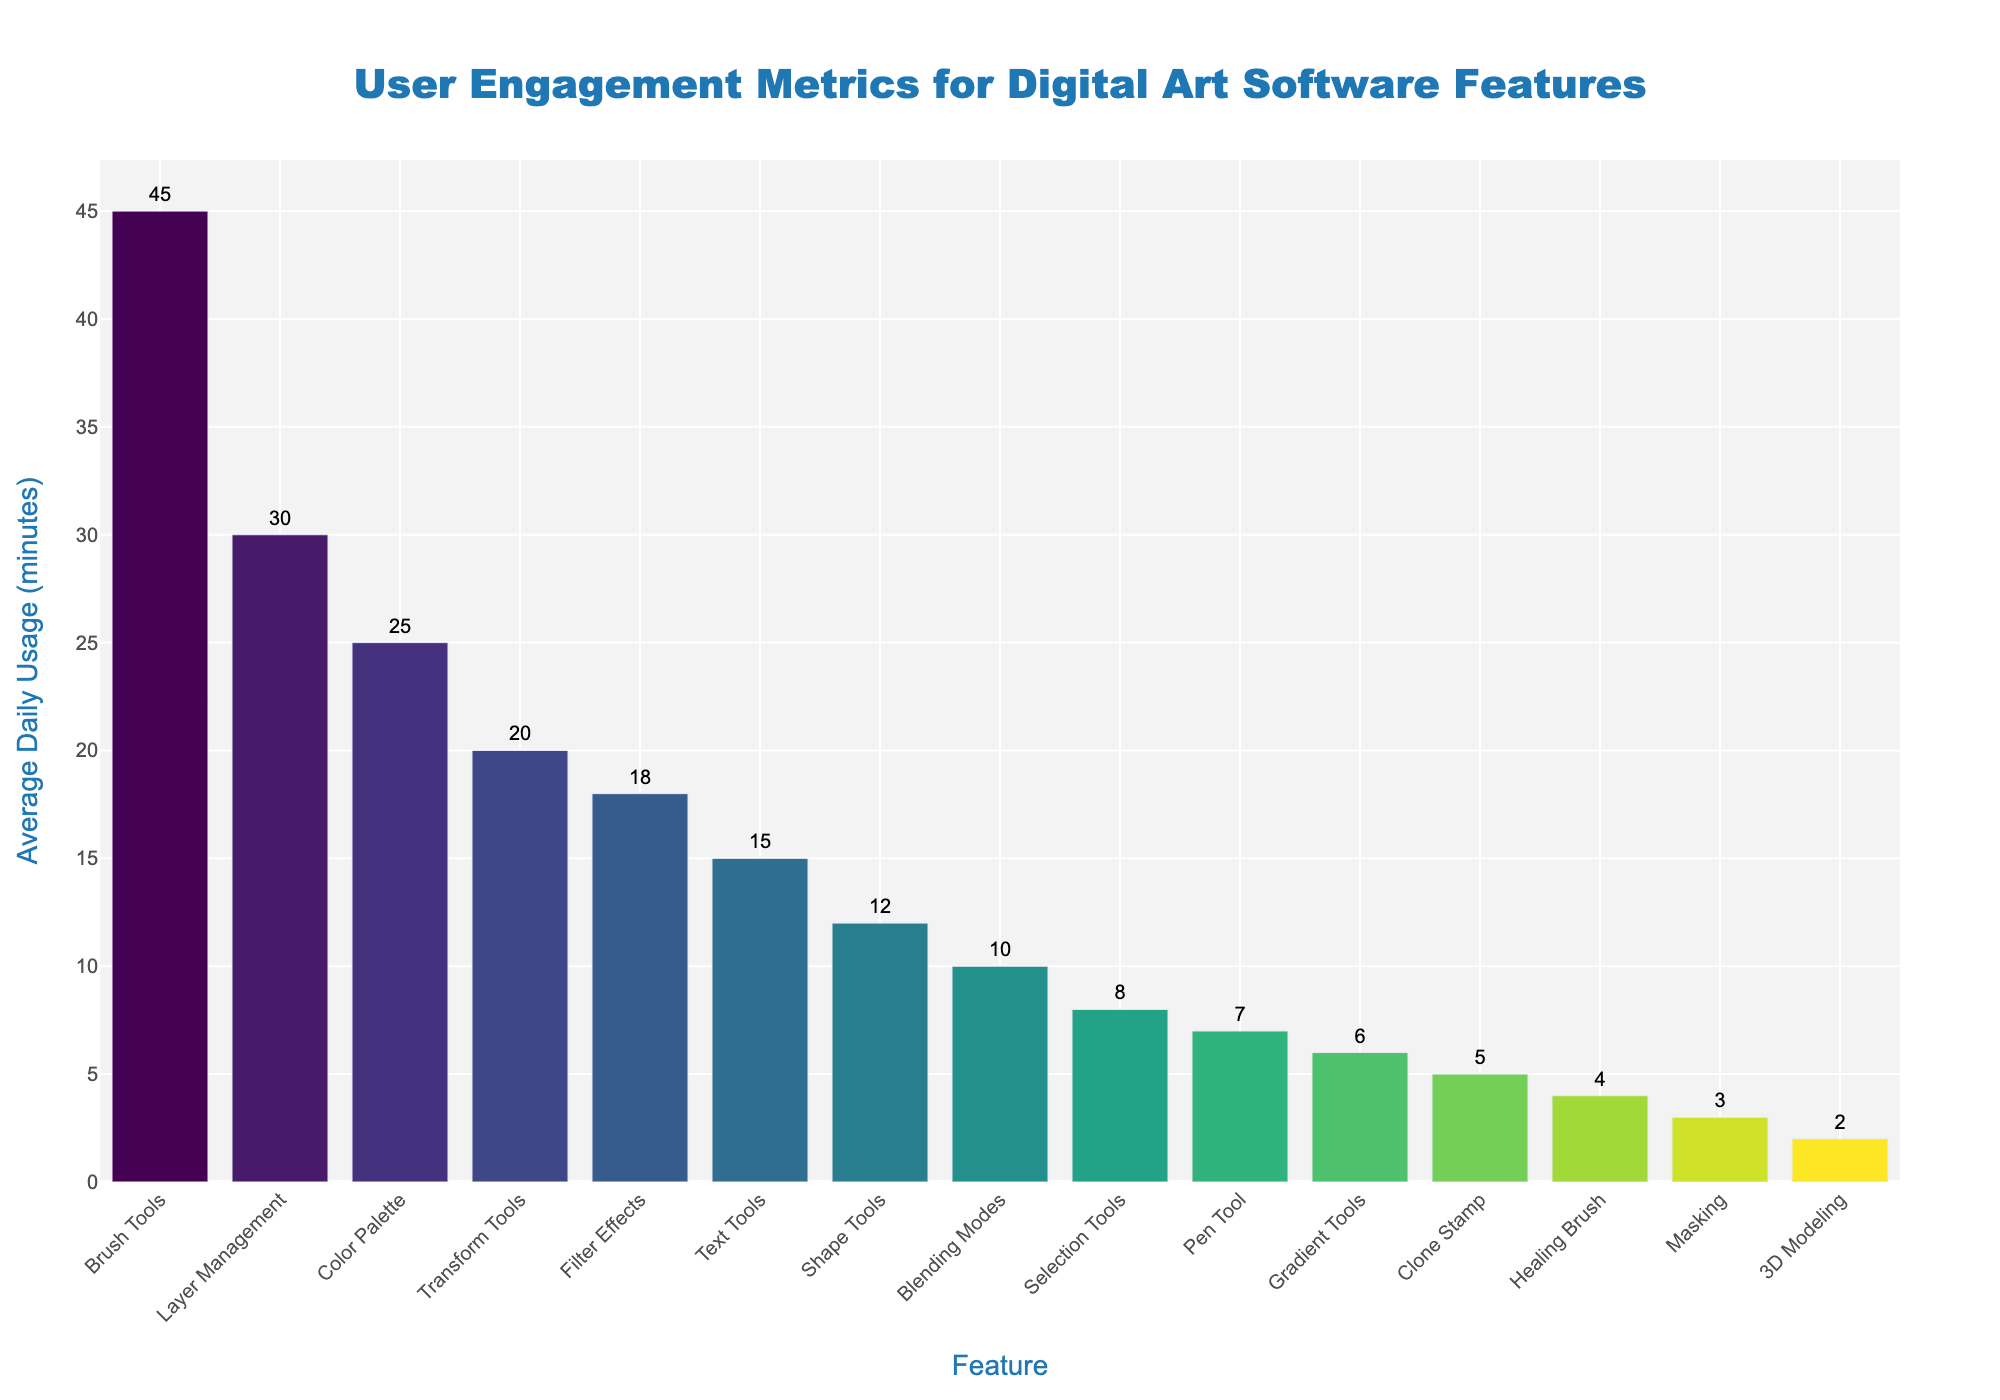Which feature has the highest average daily usage in minutes? Look at the bar with the highest value. The bar corresponding to the 'Brush Tools' feature is the tallest, indicating the highest usage.
Answer: Brush Tools Which feature has the lowest average daily usage in minutes? Look at the bar with the lowest value. The '3D Modeling' feature has the shortest bar, indicating the lowest usage.
Answer: 3D Modeling What is the total average daily usage for the 'Brush Tools' and 'Layer Management' features combined? Sum the average daily usage of 'Brush Tools' and 'Layer Management'. 'Brush Tools' is 45 minutes and 'Layer Management' is 30 minutes. Add them together: 45 + 30 = 75 minutes.
Answer: 75 minutes How much less is the average daily usage of 'Text Tools' compared to 'Color Palette'? Subtract the average daily usage of 'Text Tools' from 'Color Palette'. 'Color Palette' is 25 minutes and 'Text Tools' is 15 minutes. Perform the subtraction: 25 - 15 = 10 minutes.
Answer: 10 minutes Which features have an average daily usage greater than 20 minutes? Identify bars that have a height greater than 20 minutes. The features are 'Brush Tools', 'Layer Management', 'Color Palette', and 'Transform Tools'.
Answer: Brush Tools, Layer Management, Color Palette, Transform Tools Compare the usage of 'Filter Effects' with 'Blending Modes'. Which one is higher? Compare the height of the bars for 'Filter Effects' and 'Blending Modes'. The bar for 'Filter Effects' is taller than that for 'Blending Modes', so 'Filter Effects' has higher usage.
Answer: Filter Effects What is the average daily usage of features that have usage below 10 minutes? Identify and sum the usage of features below 10 minutes and then compute the average. Features are 'Selection Tools' (8), 'Pen Tool' (7), 'Gradient Tools' (6), 'Clone Stamp' (5), 'Healing Brush' (4), 'Masking' (3), '3D Modeling' (2). Sum these: 8 + 7 + 6 + 5 + 4 + 3 + 2 = 35. There are 7 features, so the average is 35 / 7 ≈ 5 minutes.
Answer: 5 minutes Which feature has an average daily usage exactly twice that of the 'Pen Tool'? Check the daily usage of 'Pen Tool' (7 minutes) and find the feature with twice this value. Twice 7 is 14, but since there is none, check for features with the closest higher and lower. There is none exactly twice, but none as well.
Answer: None Are there more features with a daily usage above or below 15 minutes? Count the number of features above and below 15 minutes. Features above 15 minutes are 4 (Brush Tools, Layer Management, Color Palette, Transform Tools). Features below 15 minutes are 12. More features are below 15 minutes.
Answer: Below What is the difference in usage between the 'Brush Tools' and 'Shape Tools'? Subtract the usage of 'Shape Tools' from 'Brush Tools'. 'Brush Tools' is 45 minutes and 'Shape Tools' is 12 minutes. Perform the subtraction: 45 - 12 = 33 minutes.
Answer: 33 minutes 